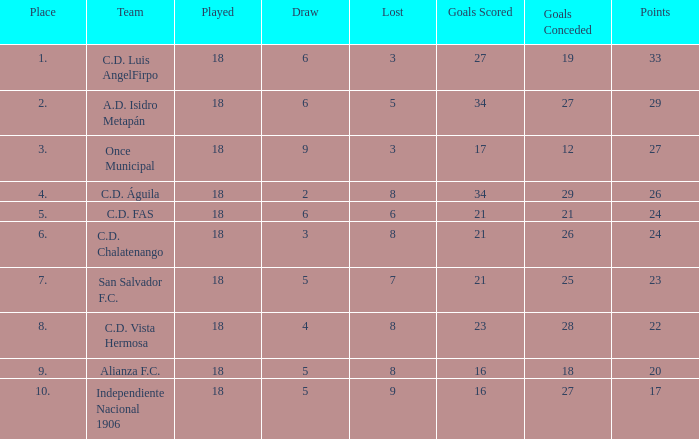What were the goal conceded that had a lost greater than 8 and more than 17 points? None. 